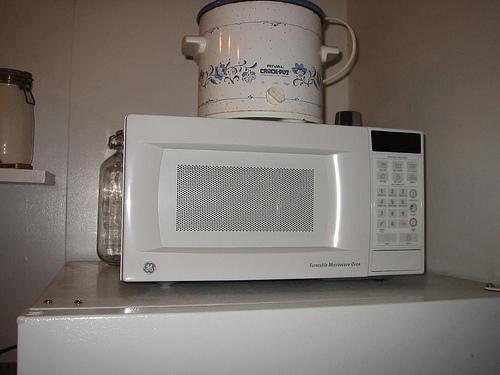Which object has a door that opens?
Select the accurate answer and provide explanation: 'Answer: answer
Rationale: rationale.'
Options: Glass jar, ceramic jar, pressure cooker, microwave. Answer: microwave.
Rationale: The small appliance has a door for one to put the food in to heat it up. 